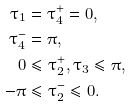<formula> <loc_0><loc_0><loc_500><loc_500>\tau _ { 1 } & = \tau _ { 4 } ^ { + } = 0 , \\ \tau _ { 4 } ^ { - } & = \pi , \\ 0 & \leq \tau _ { 2 } ^ { + } , \tau _ { 3 } \leq \pi , \\ - \pi & \leq \tau _ { 2 } ^ { - } \leq 0 .</formula> 